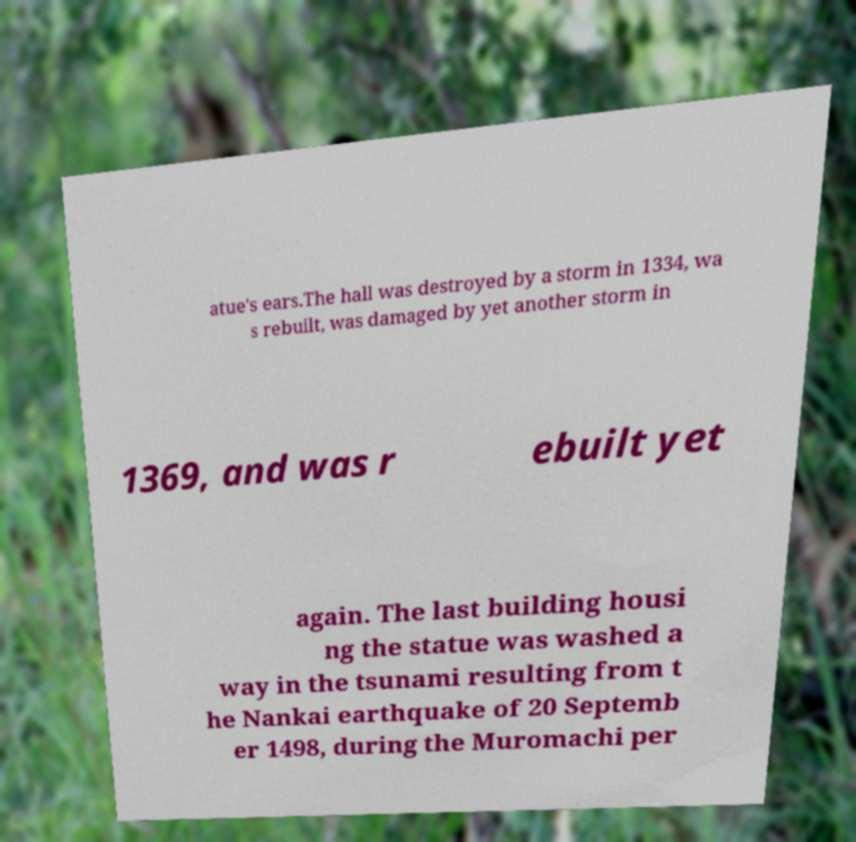What messages or text are displayed in this image? I need them in a readable, typed format. atue's ears.The hall was destroyed by a storm in 1334, wa s rebuilt, was damaged by yet another storm in 1369, and was r ebuilt yet again. The last building housi ng the statue was washed a way in the tsunami resulting from t he Nankai earthquake of 20 Septemb er 1498, during the Muromachi per 